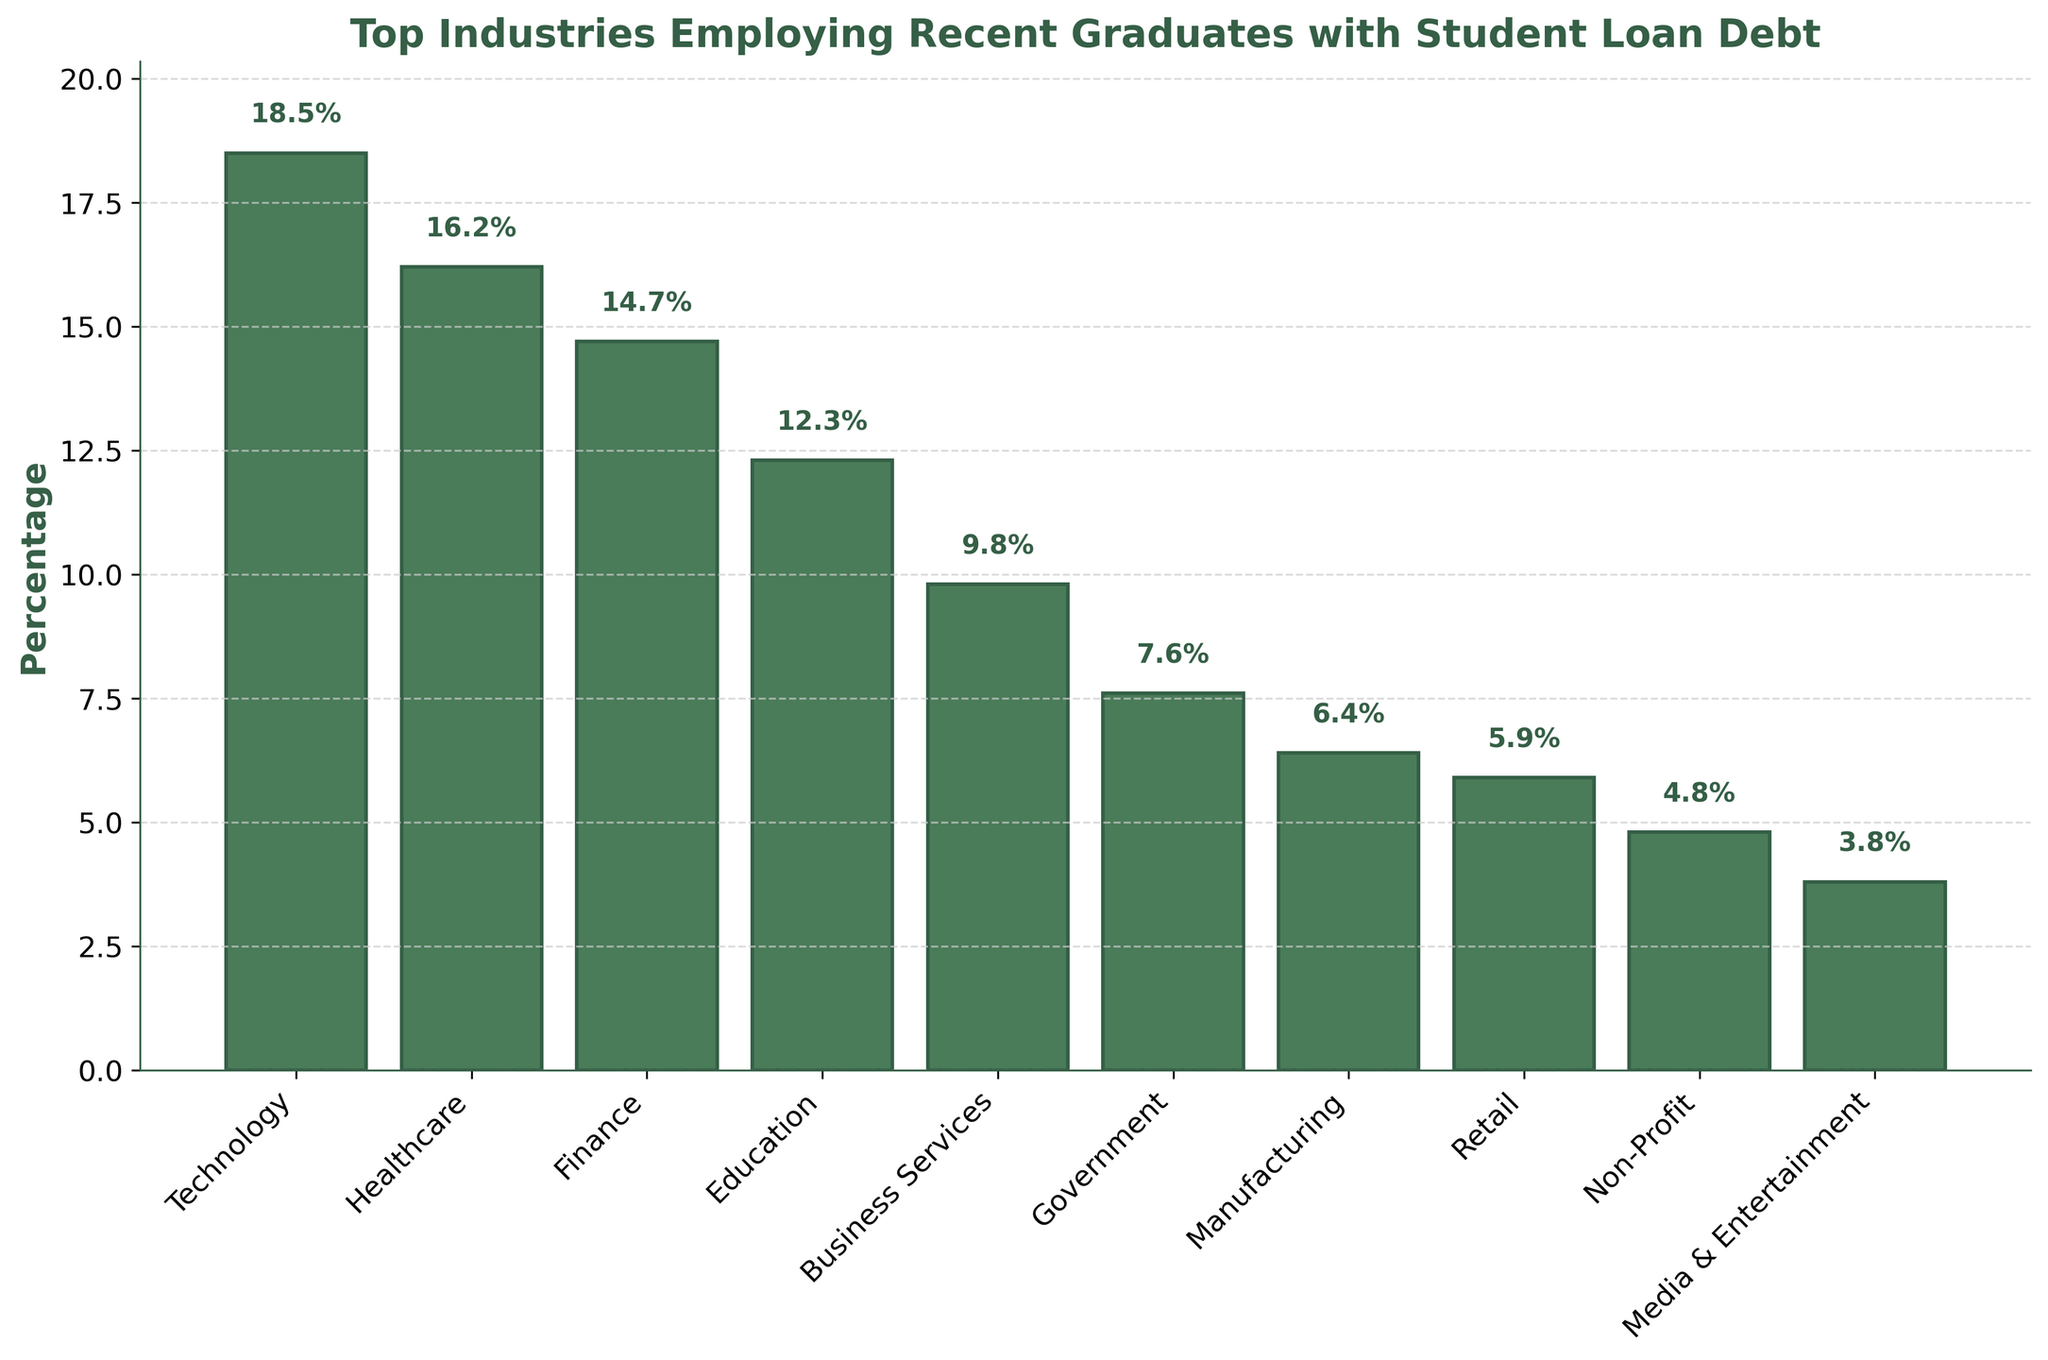What's the industry with the highest percentage of recent graduates with student loan debt? The highest bar represents the industry with the highest percentage. In this chart, it's Technology with 18.5%.
Answer: Technology Which industry employs fewer recent graduates with student loans: Healthcare or Finance? Compare the heights of the bars for Healthcare and Finance. Healthcare is at 16.2%, while Finance is at 14.7%.
Answer: Finance How much higher is the percentage of recent graduates with student loans in Technology compared to Media & Entertainment? Subtract the percentage of Media & Entertainment from Technology: 18.5% - 3.8% = 14.7%.
Answer: 14.7% What is the combined percentage of recent graduates with student loan debt employed in Government and Manufacturing? Add the percentages of Government and Manufacturing: 7.6% + 6.4% = 14%.
Answer: 14% What is the difference between the percentages of recent graduates with student loan debt employed in Business Services and Non-Profit sectors? Subtract the percentage of Non-Profit from Business Services: 9.8% - 4.8% = 5%.
Answer: 5% Which industry has the lowest percentage of recent graduates with student loan debt? The shortest bar represents the lowest percentage. In this chart, it's Media & Entertainment with 3.8%.
Answer: Media & Entertainment Are there more recent graduates with student loan debt employed in the Retail or Manufacturing sector? Compare the heights of the bars for Retail and Manufacturing. Retail is at 5.9%, while Manufacturing is at 6.4%.
Answer: Manufacturing What is the average percentage of recent graduates with student loan debt employed in the top three industries? Sum the top three percentages (Technology: 18.5%, Healthcare: 16.2%, Finance: 14.7%) and divide by 3. (18.5 + 16.2 + 14.7) / 3 = 49.4 / 3 = 16.47%.
Answer: 16.47% What is the median percentage of recent graduates with student loan debt across all listed industries? Arrange the percentages in numerical order and find the middle value. The ordered percentages are: 3.8, 4.8, 5.9, 6.4, 7.6, 9.8, 12.3, 14.7, 16.2, 18.5. The median value is the average of the 5th and 6th values: (7.6 + 9.8) / 2 = 8.7%.
Answer: 8.7% What is the percentage difference between the Education and Non-Profit industries? Subtract the percentage of Non-Profit from Education: 12.3% - 4.8% = 7.5%.
Answer: 7.5% 